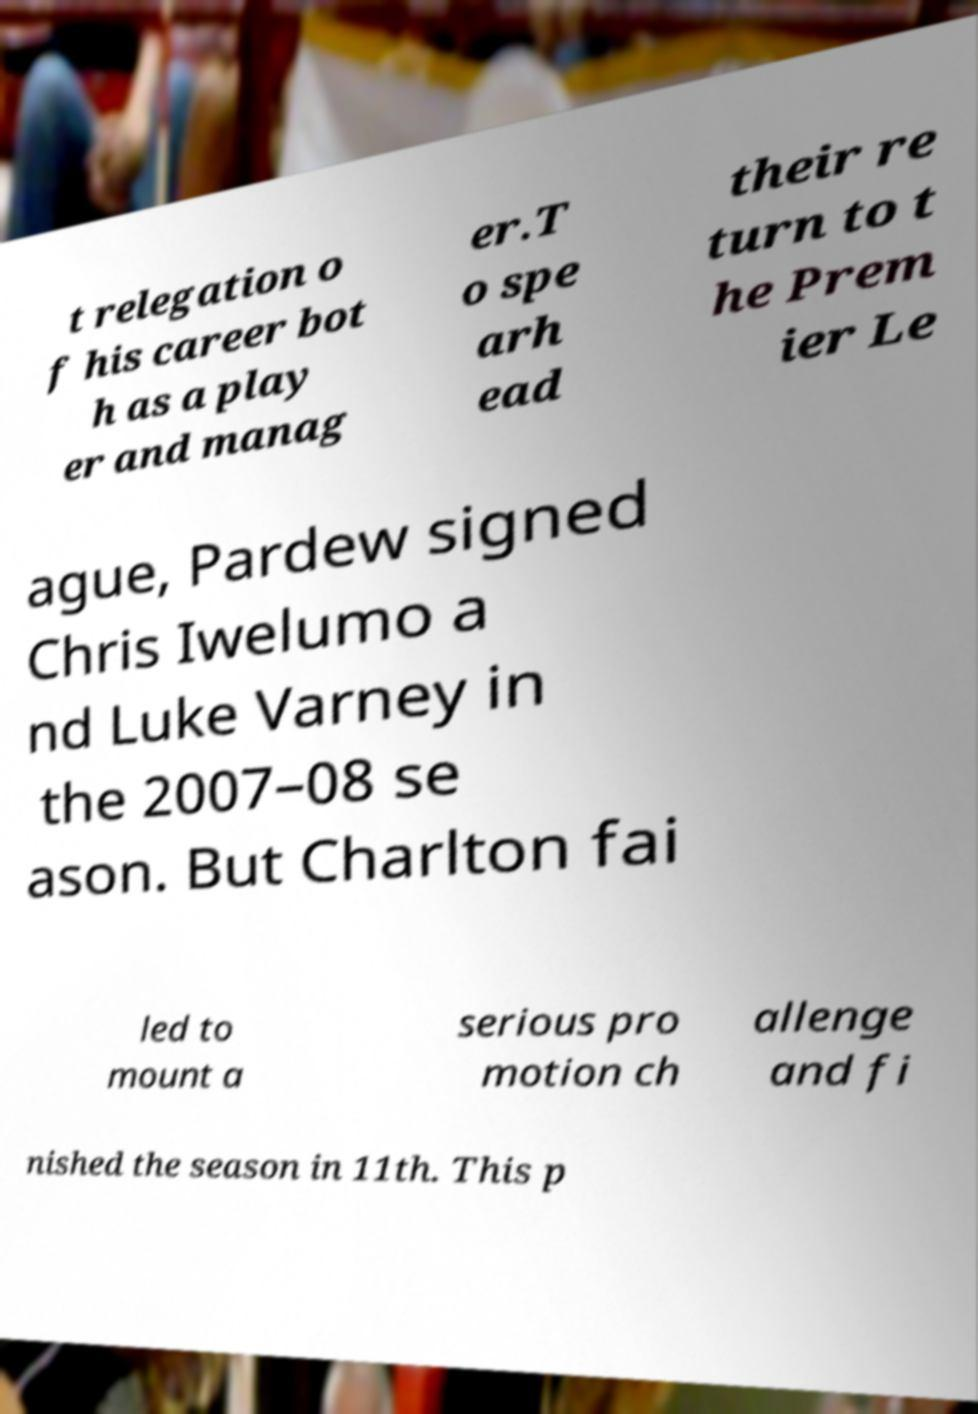Can you accurately transcribe the text from the provided image for me? t relegation o f his career bot h as a play er and manag er.T o spe arh ead their re turn to t he Prem ier Le ague, Pardew signed Chris Iwelumo a nd Luke Varney in the 2007–08 se ason. But Charlton fai led to mount a serious pro motion ch allenge and fi nished the season in 11th. This p 